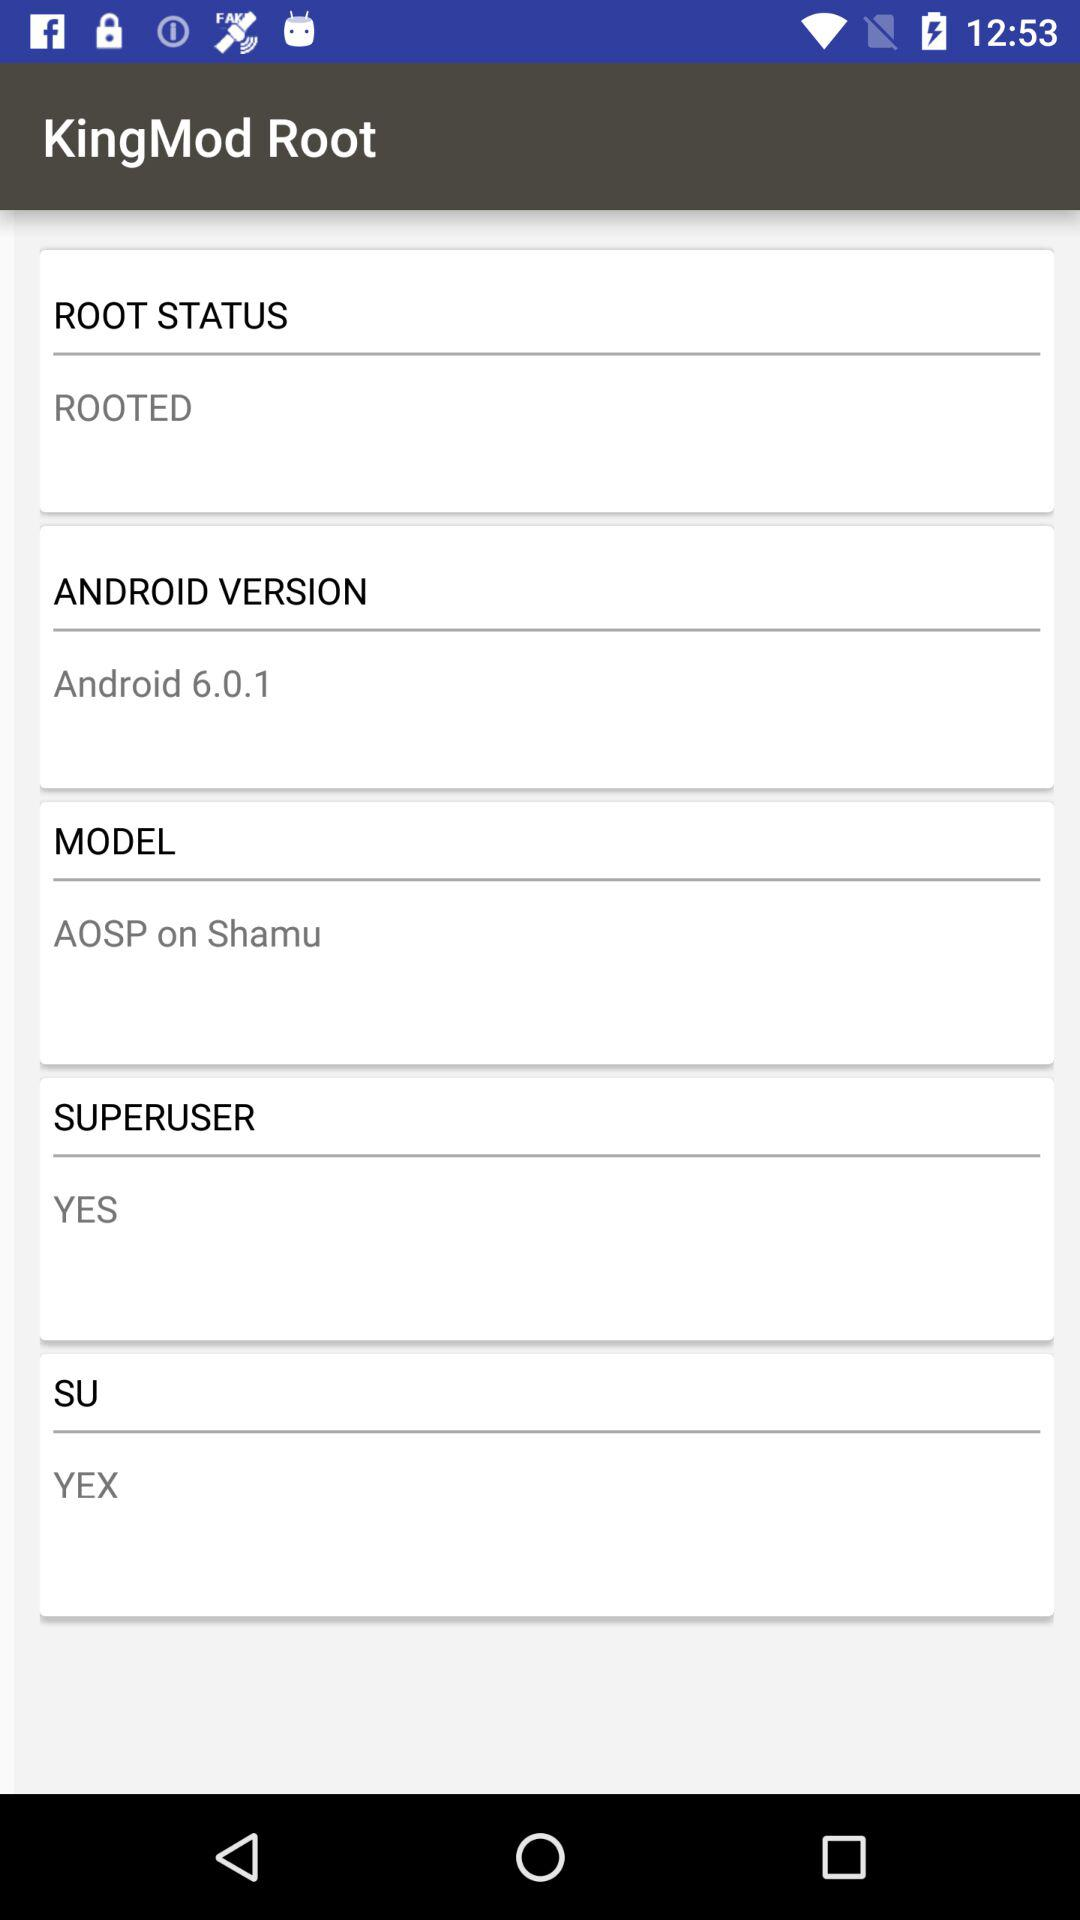What is the Android version of the device rooted by "KingMod Root"? The Android version of the device rooted by "KingMod Root" is 6.0.1. 